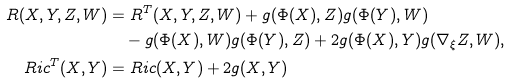<formula> <loc_0><loc_0><loc_500><loc_500>R ( X , Y , Z , W ) & = R ^ { T } ( X , Y , Z , W ) + g ( \Phi ( X ) , Z ) g ( \Phi ( Y ) , W ) \\ & \quad - g ( \Phi ( X ) , W ) g ( \Phi ( Y ) , Z ) + 2 g ( \Phi ( X ) , Y ) g ( \nabla _ { \xi } Z , W ) , \\ R i c ^ { T } ( X , Y ) & = R i c ( X , Y ) + 2 g ( X , Y )</formula> 